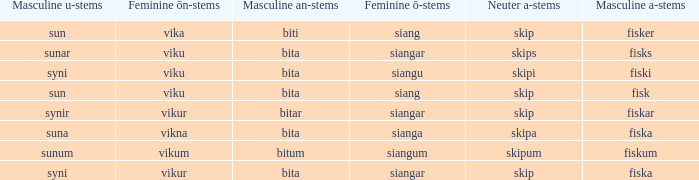What ending does siangu get for ön? Viku. 